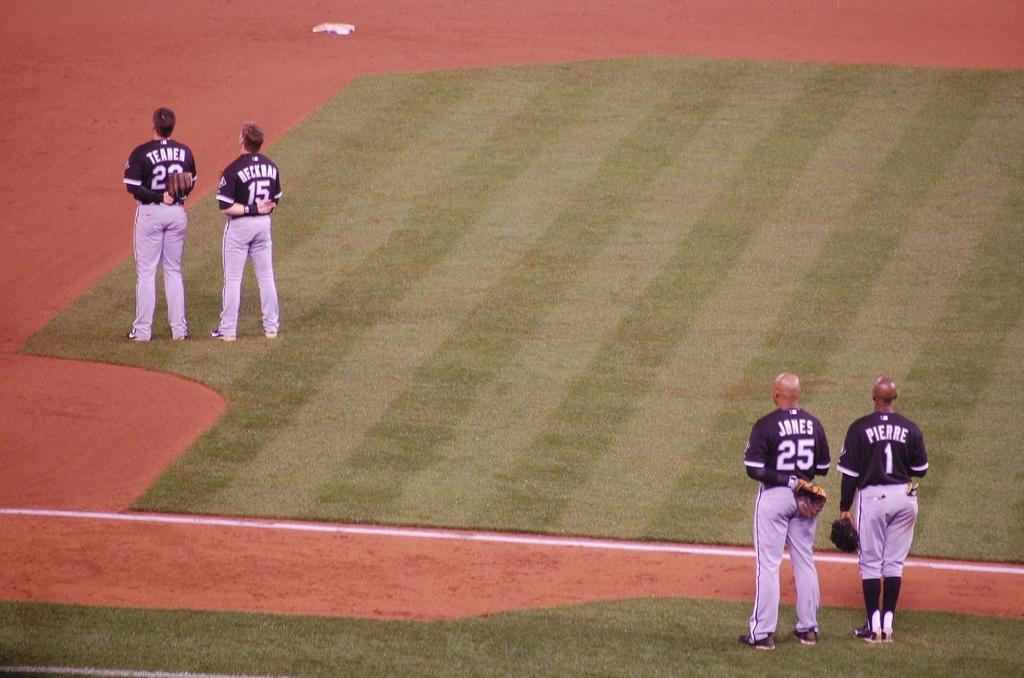<image>
Offer a succinct explanation of the picture presented. Baseball players James and Pierre stand in silence for the national anthem. 